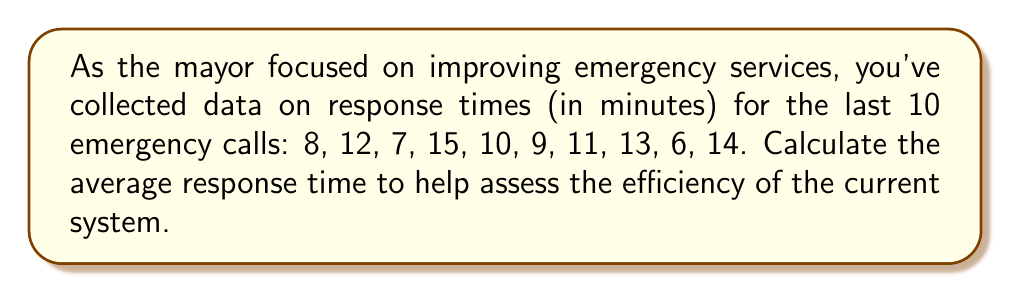Help me with this question. To calculate the average response time, we need to follow these steps:

1. Sum up all the response times:
   $$8 + 12 + 7 + 15 + 10 + 9 + 11 + 13 + 6 + 14 = 105$$

2. Count the total number of data points:
   There are 10 response times in the dataset.

3. Calculate the average by dividing the sum by the number of data points:
   $$\text{Average} = \frac{\text{Sum of all values}}{\text{Number of values}}$$
   $$\text{Average} = \frac{105}{10} = 10.5$$

Therefore, the average response time for emergency services is 10.5 minutes.
Answer: 10.5 minutes 